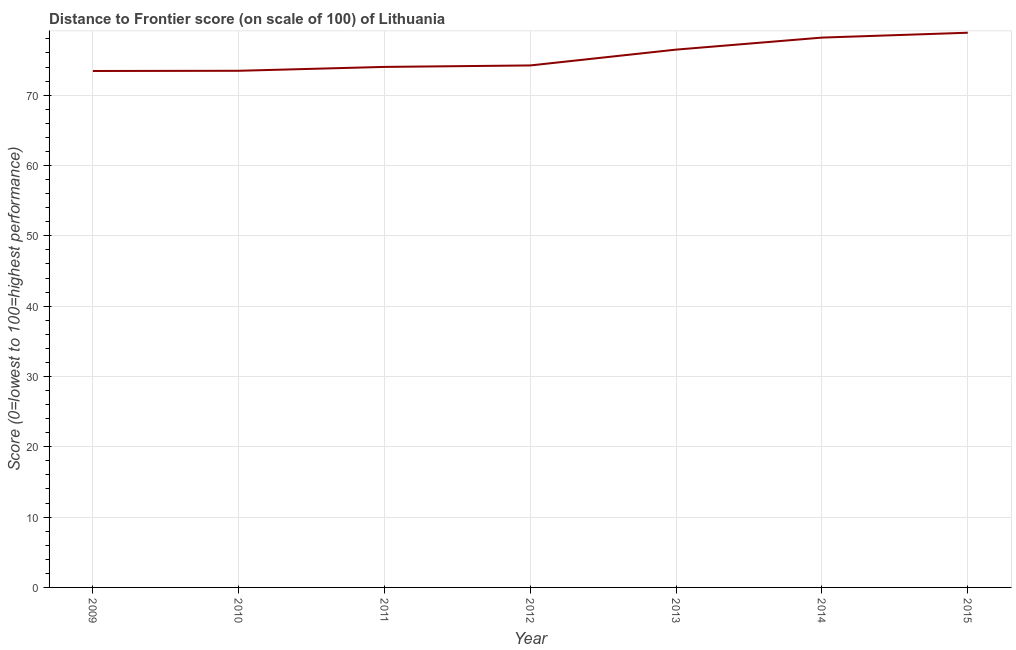What is the distance to frontier score in 2015?
Your response must be concise. 78.88. Across all years, what is the maximum distance to frontier score?
Provide a short and direct response. 78.88. Across all years, what is the minimum distance to frontier score?
Offer a very short reply. 73.44. In which year was the distance to frontier score maximum?
Offer a terse response. 2015. In which year was the distance to frontier score minimum?
Your answer should be very brief. 2009. What is the sum of the distance to frontier score?
Your response must be concise. 528.71. What is the difference between the distance to frontier score in 2009 and 2011?
Provide a succinct answer. -0.58. What is the average distance to frontier score per year?
Your answer should be very brief. 75.53. What is the median distance to frontier score?
Your response must be concise. 74.23. In how many years, is the distance to frontier score greater than 2 ?
Keep it short and to the point. 7. What is the ratio of the distance to frontier score in 2010 to that in 2012?
Provide a succinct answer. 0.99. Is the difference between the distance to frontier score in 2011 and 2015 greater than the difference between any two years?
Your answer should be compact. No. What is the difference between the highest and the second highest distance to frontier score?
Your response must be concise. 0.69. Is the sum of the distance to frontier score in 2013 and 2015 greater than the maximum distance to frontier score across all years?
Make the answer very short. Yes. What is the difference between the highest and the lowest distance to frontier score?
Provide a short and direct response. 5.44. Does the distance to frontier score monotonically increase over the years?
Offer a terse response. Yes. How many lines are there?
Ensure brevity in your answer.  1. What is the difference between two consecutive major ticks on the Y-axis?
Provide a succinct answer. 10. Are the values on the major ticks of Y-axis written in scientific E-notation?
Your answer should be compact. No. Does the graph contain any zero values?
Give a very brief answer. No. What is the title of the graph?
Keep it short and to the point. Distance to Frontier score (on scale of 100) of Lithuania. What is the label or title of the X-axis?
Offer a very short reply. Year. What is the label or title of the Y-axis?
Make the answer very short. Score (0=lowest to 100=highest performance). What is the Score (0=lowest to 100=highest performance) of 2009?
Offer a very short reply. 73.44. What is the Score (0=lowest to 100=highest performance) of 2010?
Your answer should be very brief. 73.47. What is the Score (0=lowest to 100=highest performance) of 2011?
Keep it short and to the point. 74.02. What is the Score (0=lowest to 100=highest performance) in 2012?
Your answer should be very brief. 74.23. What is the Score (0=lowest to 100=highest performance) of 2013?
Provide a short and direct response. 76.48. What is the Score (0=lowest to 100=highest performance) of 2014?
Provide a short and direct response. 78.19. What is the Score (0=lowest to 100=highest performance) in 2015?
Provide a succinct answer. 78.88. What is the difference between the Score (0=lowest to 100=highest performance) in 2009 and 2010?
Provide a succinct answer. -0.03. What is the difference between the Score (0=lowest to 100=highest performance) in 2009 and 2011?
Offer a very short reply. -0.58. What is the difference between the Score (0=lowest to 100=highest performance) in 2009 and 2012?
Make the answer very short. -0.79. What is the difference between the Score (0=lowest to 100=highest performance) in 2009 and 2013?
Give a very brief answer. -3.04. What is the difference between the Score (0=lowest to 100=highest performance) in 2009 and 2014?
Ensure brevity in your answer.  -4.75. What is the difference between the Score (0=lowest to 100=highest performance) in 2009 and 2015?
Ensure brevity in your answer.  -5.44. What is the difference between the Score (0=lowest to 100=highest performance) in 2010 and 2011?
Keep it short and to the point. -0.55. What is the difference between the Score (0=lowest to 100=highest performance) in 2010 and 2012?
Provide a succinct answer. -0.76. What is the difference between the Score (0=lowest to 100=highest performance) in 2010 and 2013?
Keep it short and to the point. -3.01. What is the difference between the Score (0=lowest to 100=highest performance) in 2010 and 2014?
Your response must be concise. -4.72. What is the difference between the Score (0=lowest to 100=highest performance) in 2010 and 2015?
Your answer should be very brief. -5.41. What is the difference between the Score (0=lowest to 100=highest performance) in 2011 and 2012?
Make the answer very short. -0.21. What is the difference between the Score (0=lowest to 100=highest performance) in 2011 and 2013?
Give a very brief answer. -2.46. What is the difference between the Score (0=lowest to 100=highest performance) in 2011 and 2014?
Give a very brief answer. -4.17. What is the difference between the Score (0=lowest to 100=highest performance) in 2011 and 2015?
Provide a succinct answer. -4.86. What is the difference between the Score (0=lowest to 100=highest performance) in 2012 and 2013?
Offer a terse response. -2.25. What is the difference between the Score (0=lowest to 100=highest performance) in 2012 and 2014?
Make the answer very short. -3.96. What is the difference between the Score (0=lowest to 100=highest performance) in 2012 and 2015?
Your answer should be compact. -4.65. What is the difference between the Score (0=lowest to 100=highest performance) in 2013 and 2014?
Offer a terse response. -1.71. What is the difference between the Score (0=lowest to 100=highest performance) in 2013 and 2015?
Offer a very short reply. -2.4. What is the difference between the Score (0=lowest to 100=highest performance) in 2014 and 2015?
Keep it short and to the point. -0.69. What is the ratio of the Score (0=lowest to 100=highest performance) in 2009 to that in 2010?
Keep it short and to the point. 1. What is the ratio of the Score (0=lowest to 100=highest performance) in 2009 to that in 2011?
Your answer should be compact. 0.99. What is the ratio of the Score (0=lowest to 100=highest performance) in 2009 to that in 2012?
Offer a very short reply. 0.99. What is the ratio of the Score (0=lowest to 100=highest performance) in 2009 to that in 2013?
Ensure brevity in your answer.  0.96. What is the ratio of the Score (0=lowest to 100=highest performance) in 2009 to that in 2014?
Keep it short and to the point. 0.94. What is the ratio of the Score (0=lowest to 100=highest performance) in 2010 to that in 2012?
Keep it short and to the point. 0.99. What is the ratio of the Score (0=lowest to 100=highest performance) in 2010 to that in 2015?
Your answer should be compact. 0.93. What is the ratio of the Score (0=lowest to 100=highest performance) in 2011 to that in 2013?
Your answer should be very brief. 0.97. What is the ratio of the Score (0=lowest to 100=highest performance) in 2011 to that in 2014?
Ensure brevity in your answer.  0.95. What is the ratio of the Score (0=lowest to 100=highest performance) in 2011 to that in 2015?
Your answer should be very brief. 0.94. What is the ratio of the Score (0=lowest to 100=highest performance) in 2012 to that in 2013?
Provide a short and direct response. 0.97. What is the ratio of the Score (0=lowest to 100=highest performance) in 2012 to that in 2014?
Your response must be concise. 0.95. What is the ratio of the Score (0=lowest to 100=highest performance) in 2012 to that in 2015?
Keep it short and to the point. 0.94. 